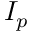<formula> <loc_0><loc_0><loc_500><loc_500>I _ { p }</formula> 